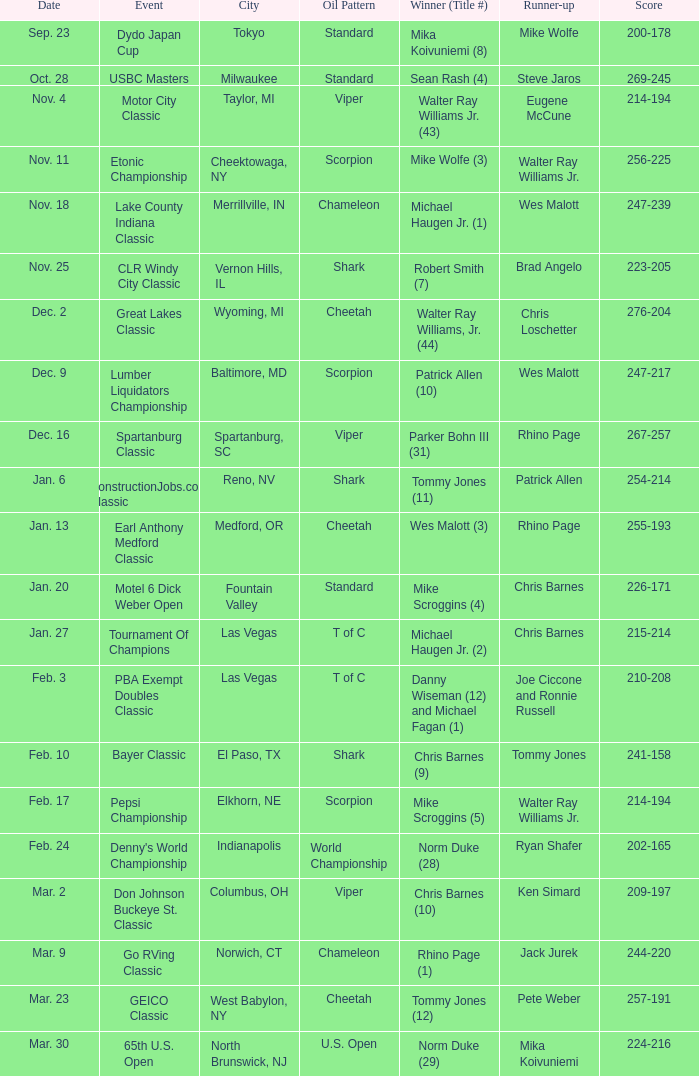Write the full table. {'header': ['Date', 'Event', 'City', 'Oil Pattern', 'Winner (Title #)', 'Runner-up', 'Score'], 'rows': [['Sep. 23', 'Dydo Japan Cup', 'Tokyo', 'Standard', 'Mika Koivuniemi (8)', 'Mike Wolfe', '200-178'], ['Oct. 28', 'USBC Masters', 'Milwaukee', 'Standard', 'Sean Rash (4)', 'Steve Jaros', '269-245'], ['Nov. 4', 'Motor City Classic', 'Taylor, MI', 'Viper', 'Walter Ray Williams Jr. (43)', 'Eugene McCune', '214-194'], ['Nov. 11', 'Etonic Championship', 'Cheektowaga, NY', 'Scorpion', 'Mike Wolfe (3)', 'Walter Ray Williams Jr.', '256-225'], ['Nov. 18', 'Lake County Indiana Classic', 'Merrillville, IN', 'Chameleon', 'Michael Haugen Jr. (1)', 'Wes Malott', '247-239'], ['Nov. 25', 'CLR Windy City Classic', 'Vernon Hills, IL', 'Shark', 'Robert Smith (7)', 'Brad Angelo', '223-205'], ['Dec. 2', 'Great Lakes Classic', 'Wyoming, MI', 'Cheetah', 'Walter Ray Williams, Jr. (44)', 'Chris Loschetter', '276-204'], ['Dec. 9', 'Lumber Liquidators Championship', 'Baltimore, MD', 'Scorpion', 'Patrick Allen (10)', 'Wes Malott', '247-217'], ['Dec. 16', 'Spartanburg Classic', 'Spartanburg, SC', 'Viper', 'Parker Bohn III (31)', 'Rhino Page', '267-257'], ['Jan. 6', 'ConstructionJobs.com Classic', 'Reno, NV', 'Shark', 'Tommy Jones (11)', 'Patrick Allen', '254-214'], ['Jan. 13', 'Earl Anthony Medford Classic', 'Medford, OR', 'Cheetah', 'Wes Malott (3)', 'Rhino Page', '255-193'], ['Jan. 20', 'Motel 6 Dick Weber Open', 'Fountain Valley', 'Standard', 'Mike Scroggins (4)', 'Chris Barnes', '226-171'], ['Jan. 27', 'Tournament Of Champions', 'Las Vegas', 'T of C', 'Michael Haugen Jr. (2)', 'Chris Barnes', '215-214'], ['Feb. 3', 'PBA Exempt Doubles Classic', 'Las Vegas', 'T of C', 'Danny Wiseman (12) and Michael Fagan (1)', 'Joe Ciccone and Ronnie Russell', '210-208'], ['Feb. 10', 'Bayer Classic', 'El Paso, TX', 'Shark', 'Chris Barnes (9)', 'Tommy Jones', '241-158'], ['Feb. 17', 'Pepsi Championship', 'Elkhorn, NE', 'Scorpion', 'Mike Scroggins (5)', 'Walter Ray Williams Jr.', '214-194'], ['Feb. 24', "Denny's World Championship", 'Indianapolis', 'World Championship', 'Norm Duke (28)', 'Ryan Shafer', '202-165'], ['Mar. 2', 'Don Johnson Buckeye St. Classic', 'Columbus, OH', 'Viper', 'Chris Barnes (10)', 'Ken Simard', '209-197'], ['Mar. 9', 'Go RVing Classic', 'Norwich, CT', 'Chameleon', 'Rhino Page (1)', 'Jack Jurek', '244-220'], ['Mar. 23', 'GEICO Classic', 'West Babylon, NY', 'Cheetah', 'Tommy Jones (12)', 'Pete Weber', '257-191'], ['Mar. 30', '65th U.S. Open', 'North Brunswick, NJ', 'U.S. Open', 'Norm Duke (29)', 'Mika Koivuniemi', '224-216']]} Name the Event which has a Score of 209-197? Don Johnson Buckeye St. Classic. 